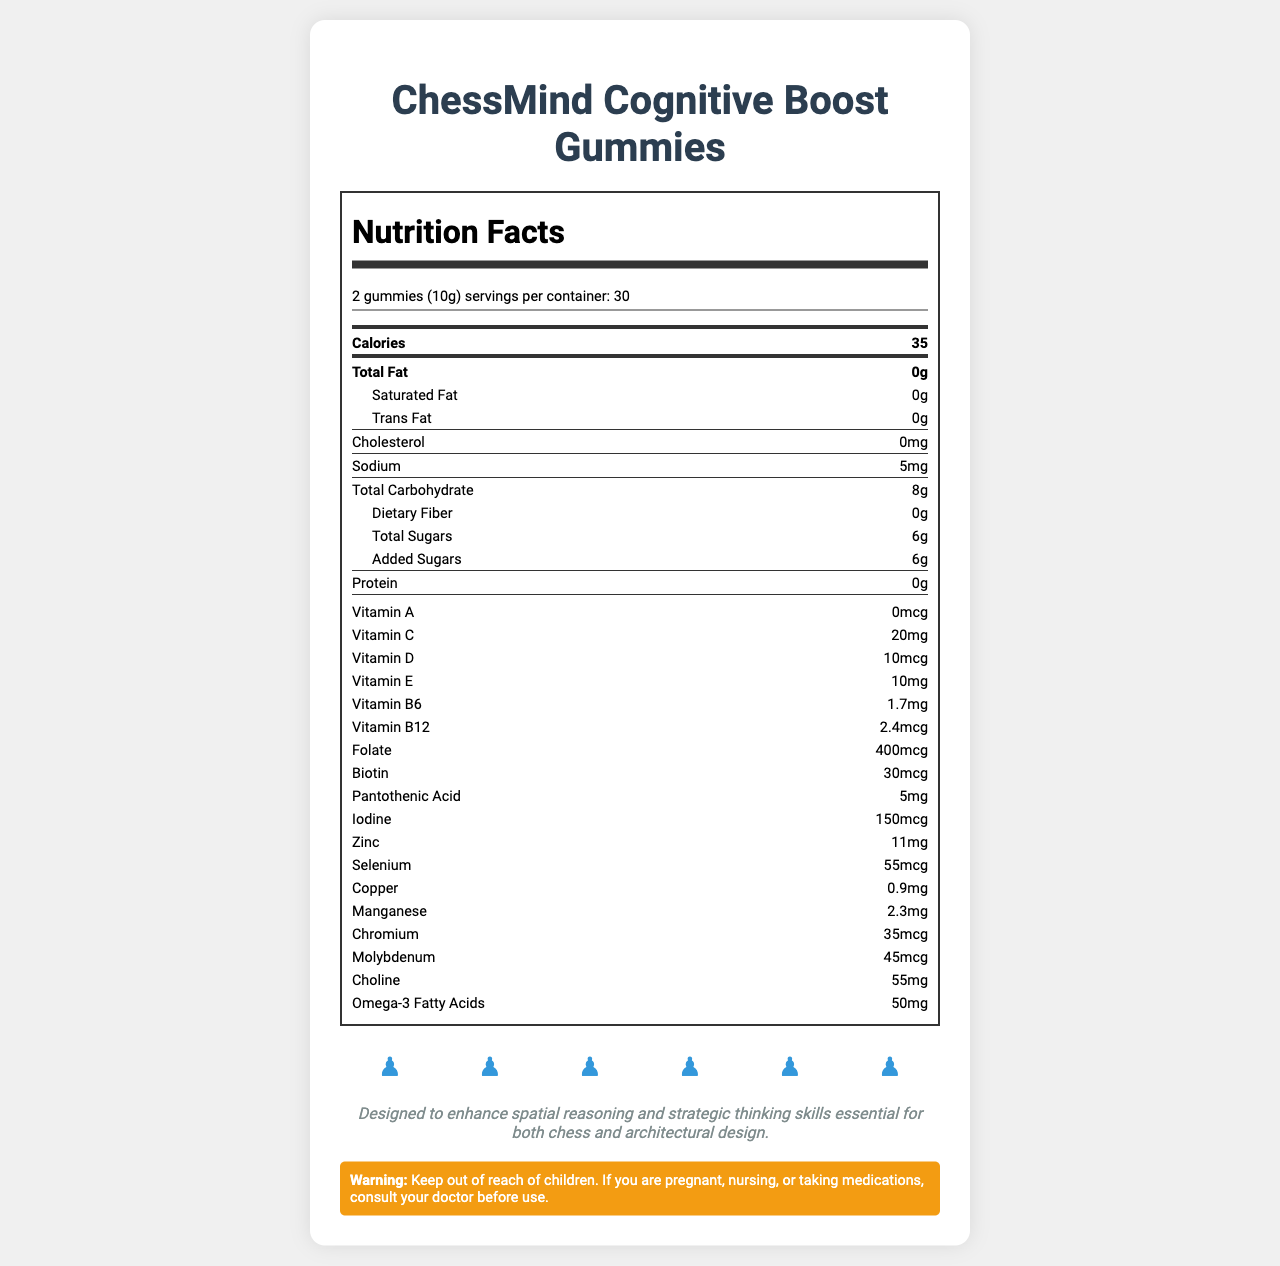what is the serving size for the product? The serving size is stated at the top of the nutrition label.
Answer: 2 gummies (10g) how many calories are in one serving? The number of calories per serving is listed near the top of the label.
Answer: 35 calories what vitamin amounts are included in each serving? These vitamin amounts are listed under the "vitamins" section of the nutrition label.
Answer: Vitamin C: 20mg, Vitamin D: 10mcg, Vitamin E: 10mg, Vitamin B6: 1.7mg, Vitamin B12: 2.4mcg, Folate: 400mcg, Biotin: 30mcg, Pantothenic Acid: 5mg how much added sugar is in one serving? The amount of added sugars is listed under "Total Sugars" in the nutrition label.
Answer: 6g What ingredients are used for flavoring the gummies? The flavors are listed under the "other ingredients" section.
Answer: Natural flavors (strawberry, blueberry) how many servings are there in one container? A. 10 B. 20 C. 30 D. 40 The number of servings per container is indicated as 30 near the top of the nutrition label.
Answer: C. 30 which of the following minerals is NOT included in the gummies? 1. Iodine 2. Gold 3. Zinc 4. Copper Minerals such as Iodine, Zinc, and Copper are listed in the nutrition label, but Gold is not.
Answer: 2. Gold Is this product suitable for children under 4 years old? The suggested use indicates that it's for children 4 years and older.
Answer: No summarize the purpose and main idea of the document. The document comprehensively details the nutritional contents and the purpose of the "ChessMind Cognitive Boost Gummies," which are designed to improve cognitive function and strategic thinking, particularly in children.
Answer: The document provides detailed nutritional information about the "ChessMind Cognitive Boost Gummies," a chess piece-shaped vitamin gummy set designed for cognitive function. It includes serving sizes, vitamin and mineral content, and other ingredients. The document also highlights the product's chess-themed design meant to enhance cognitive skills. Are the gummies intended to help with spatial reasoning and strategic thinking? The document mentions that the gummies are designed to enhance spatial reasoning and strategic thinking skills.
Answer: Yes which chess piece shapes do the gummies come in? The chess piece shapes are listed near the bottom of the document.
Answer: Pawn, Knight, Bishop, Rook, Queen, King Can you tell if the product is made of organic ingredients based on the document? The "other ingredients" section lists "Organic tapioca syrup" and "Organic cane sugar."
Answer: Yes Are there allergens present in the manufacturing facility? It is noted that the product is manufactured in a facility that also processes soy and tree nuts.
Answer: Yes What should you do if you are pregnant, nursing, or taking medications before using the product? The warning section advises consulting a doctor before use if pregnant, nursing, or on medications.
Answer: Consult your doctor Does the document provide information about the product manufacturer? The document does not mention the manufacturer details.
Answer: Not enough information 